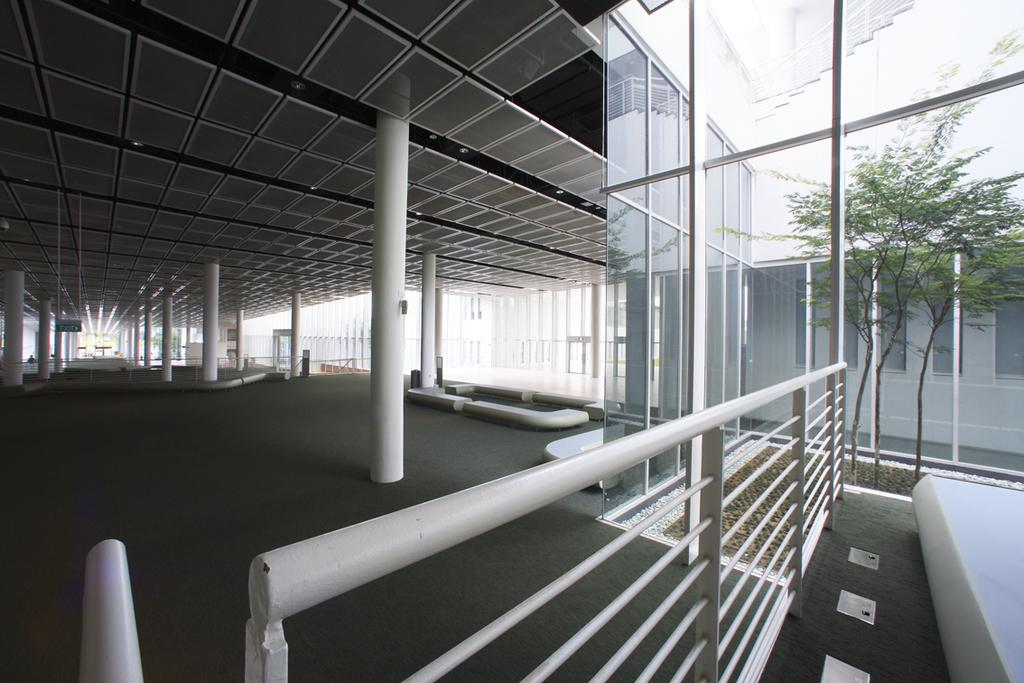What type of view is shown in the image? The image shows an inner view of a building. What part of the building can be seen in the image? There is a roof and a floor visible in the image. What is on the roof in the image? The roof has some lights in the image. What is on the floor in the image? There are objects on the floor in the image. Can you describe any vegetation in the image? There is a plant in the image. What type of architectural feature is present in the image? Glass doors are present in the image. What type of button is being pushed by the minister in the image? There is no minister or button present in the image. What color is the sock on the plant in the image? There is no sock present in the image, and the plant is not associated with any clothing items. 